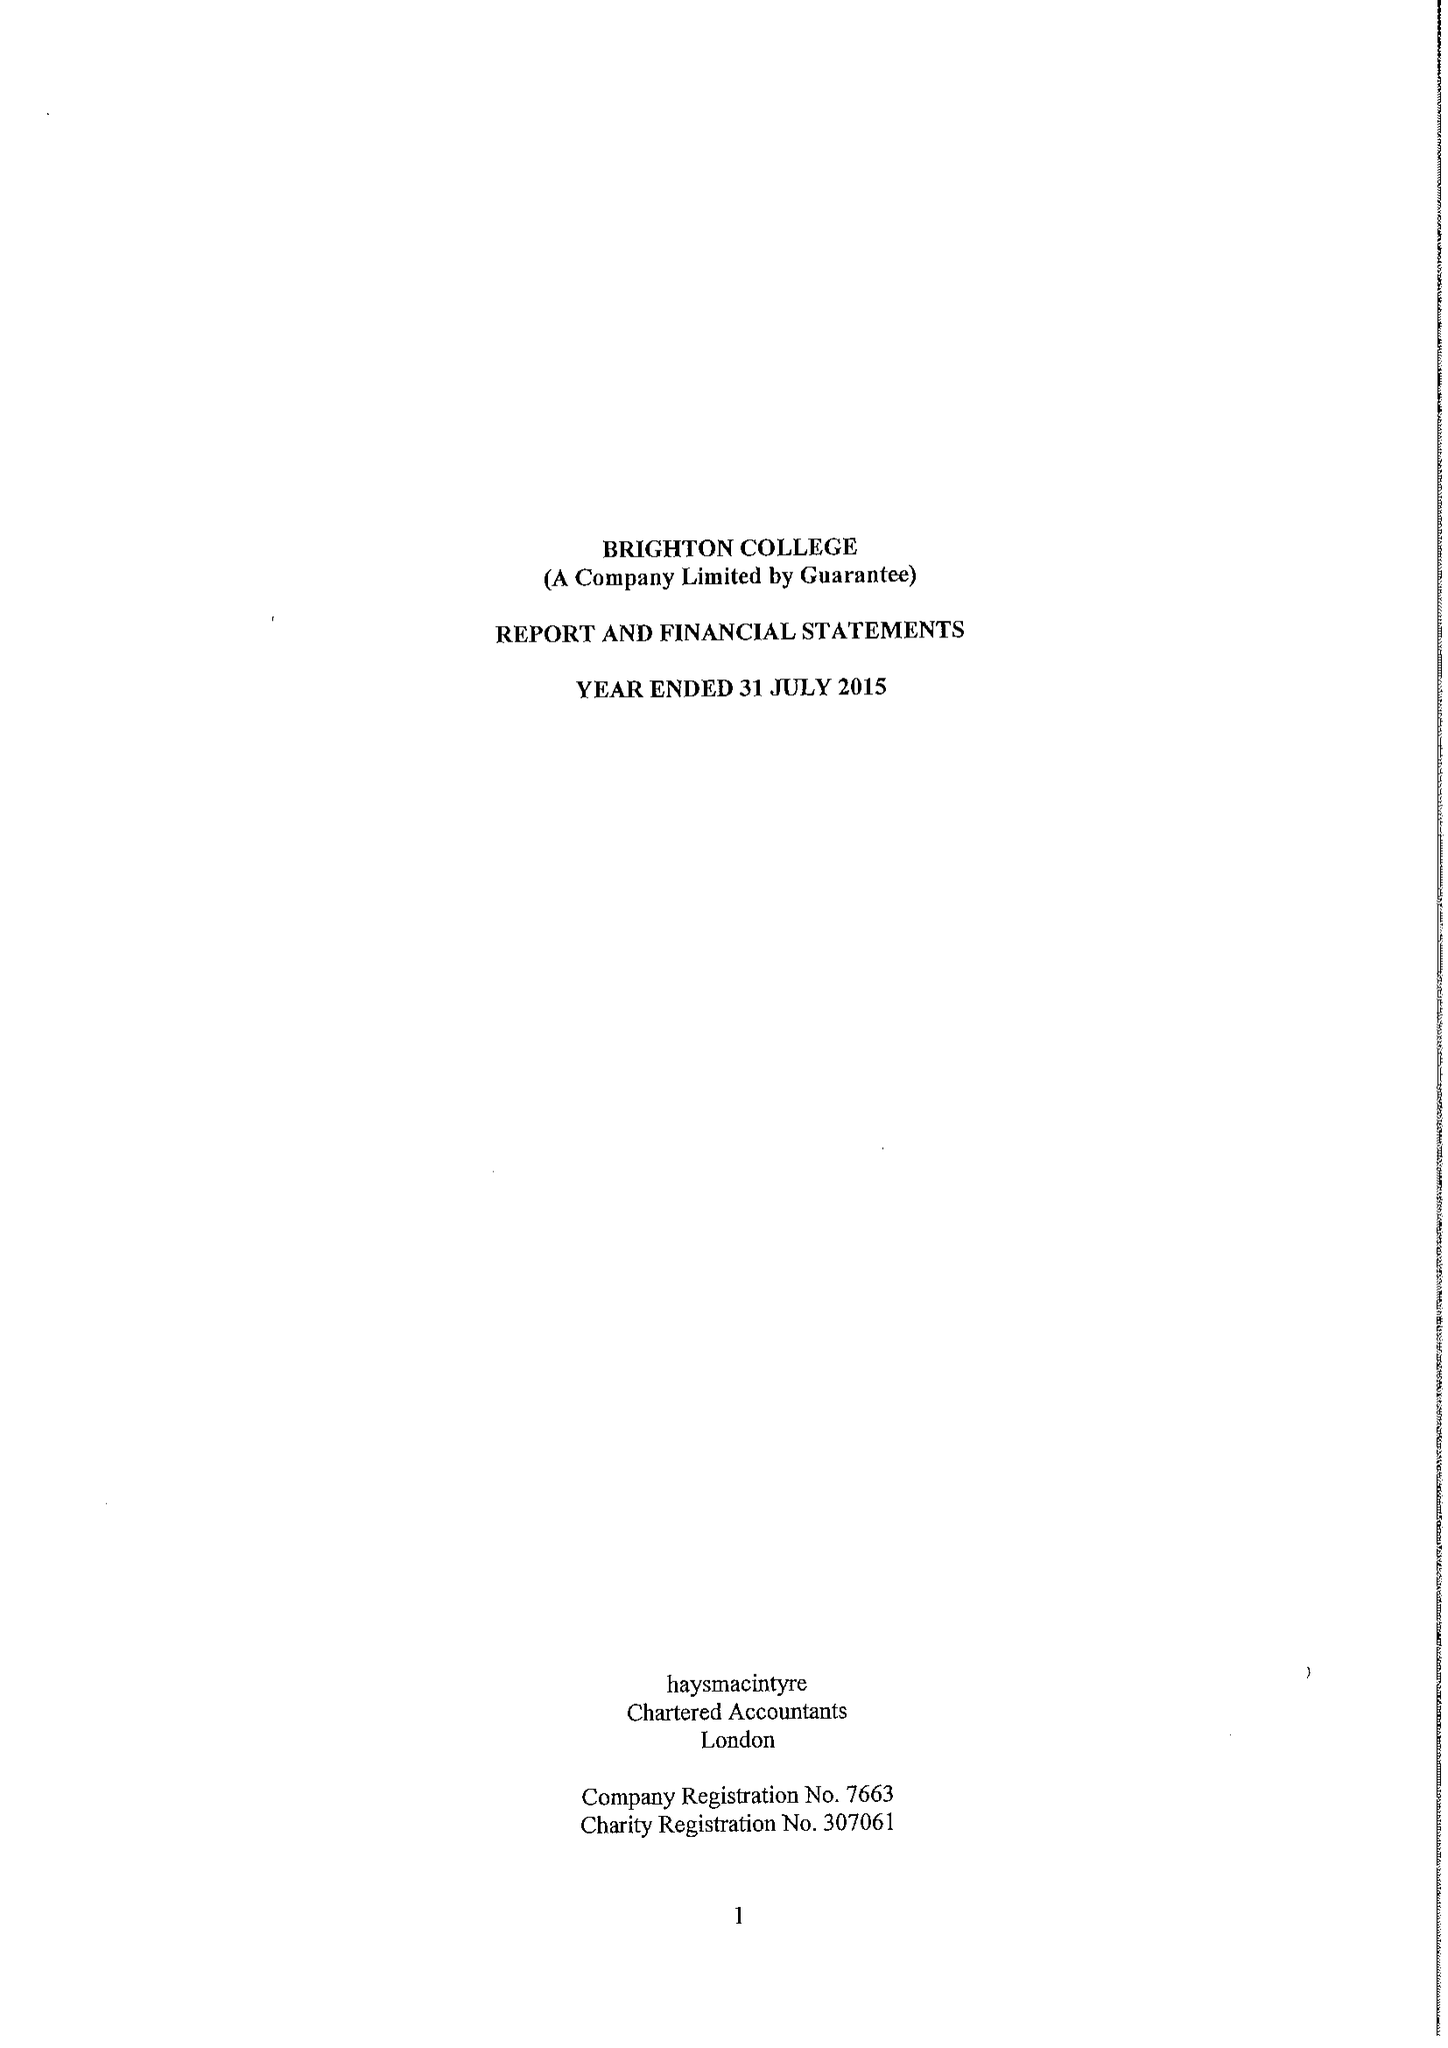What is the value for the spending_annually_in_british_pounds?
Answer the question using a single word or phrase. 33203209.00 